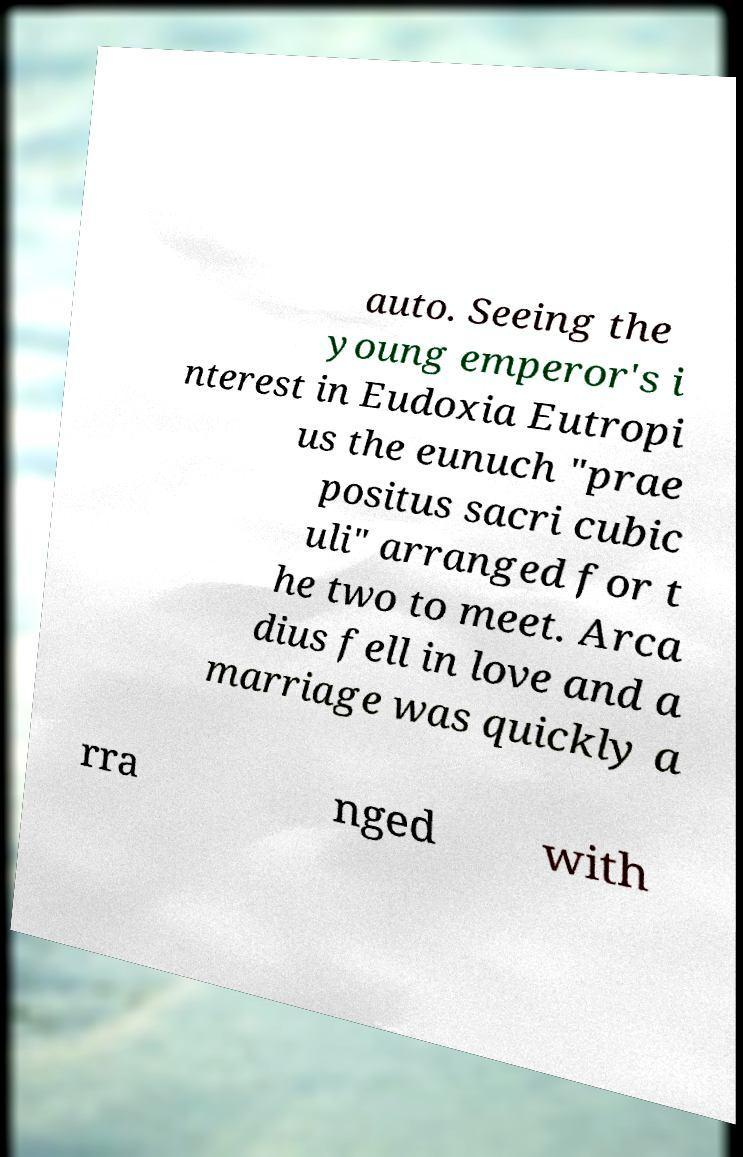I need the written content from this picture converted into text. Can you do that? auto. Seeing the young emperor's i nterest in Eudoxia Eutropi us the eunuch "prae positus sacri cubic uli" arranged for t he two to meet. Arca dius fell in love and a marriage was quickly a rra nged with 